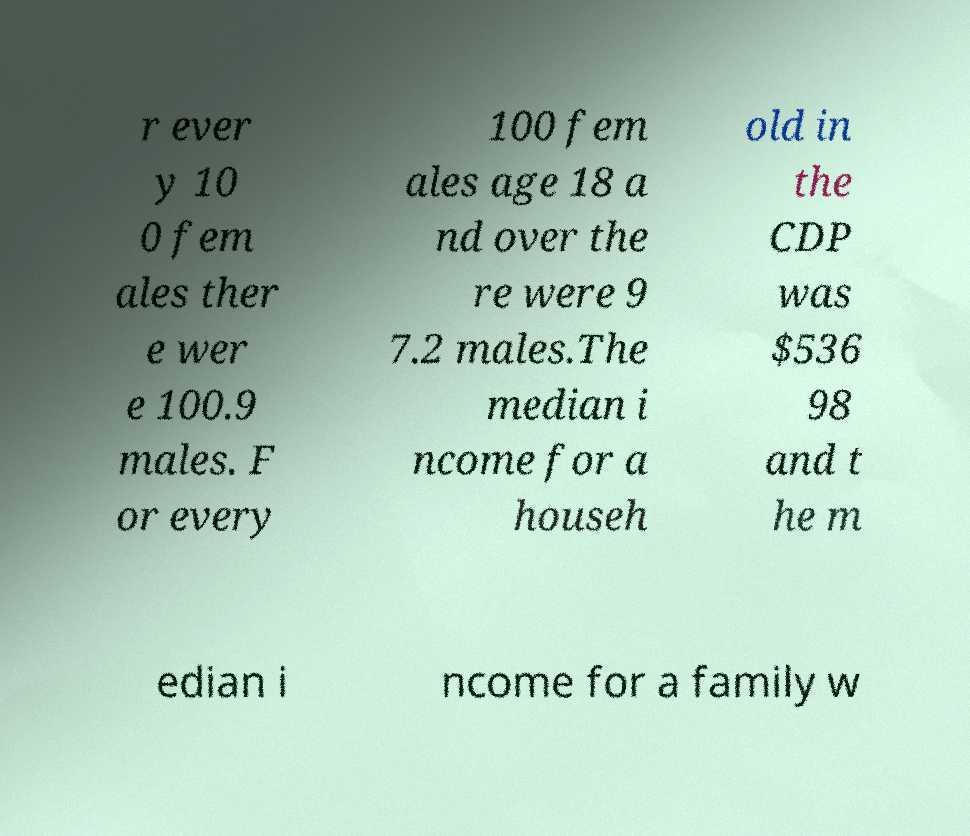Please read and relay the text visible in this image. What does it say? r ever y 10 0 fem ales ther e wer e 100.9 males. F or every 100 fem ales age 18 a nd over the re were 9 7.2 males.The median i ncome for a househ old in the CDP was $536 98 and t he m edian i ncome for a family w 